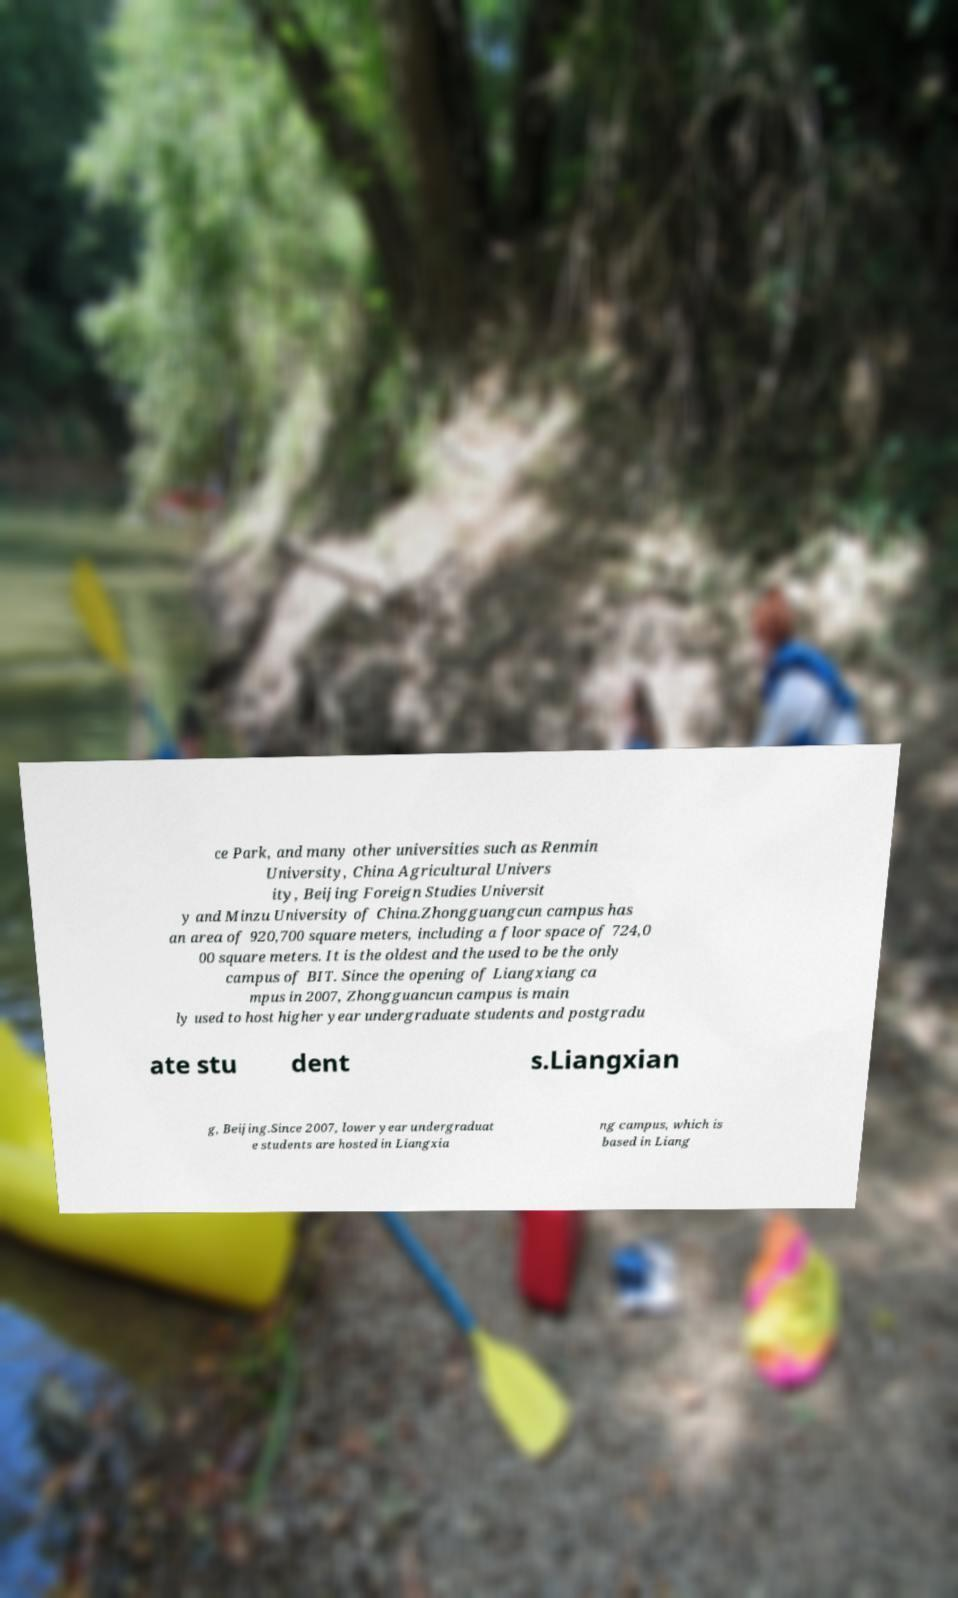Can you accurately transcribe the text from the provided image for me? ce Park, and many other universities such as Renmin University, China Agricultural Univers ity, Beijing Foreign Studies Universit y and Minzu University of China.Zhongguangcun campus has an area of 920,700 square meters, including a floor space of 724,0 00 square meters. It is the oldest and the used to be the only campus of BIT. Since the opening of Liangxiang ca mpus in 2007, Zhongguancun campus is main ly used to host higher year undergraduate students and postgradu ate stu dent s.Liangxian g, Beijing.Since 2007, lower year undergraduat e students are hosted in Liangxia ng campus, which is based in Liang 